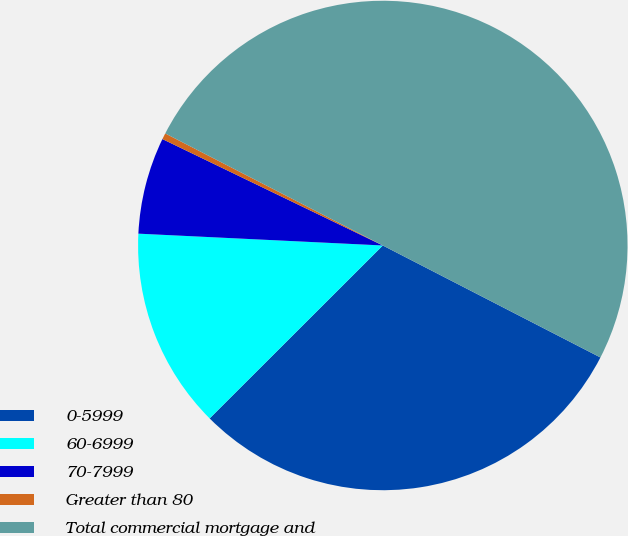Convert chart. <chart><loc_0><loc_0><loc_500><loc_500><pie_chart><fcel>0-5999<fcel>60-6999<fcel>70-7999<fcel>Greater than 80<fcel>Total commercial mortgage and<nl><fcel>29.95%<fcel>13.26%<fcel>6.39%<fcel>0.41%<fcel>50.0%<nl></chart> 